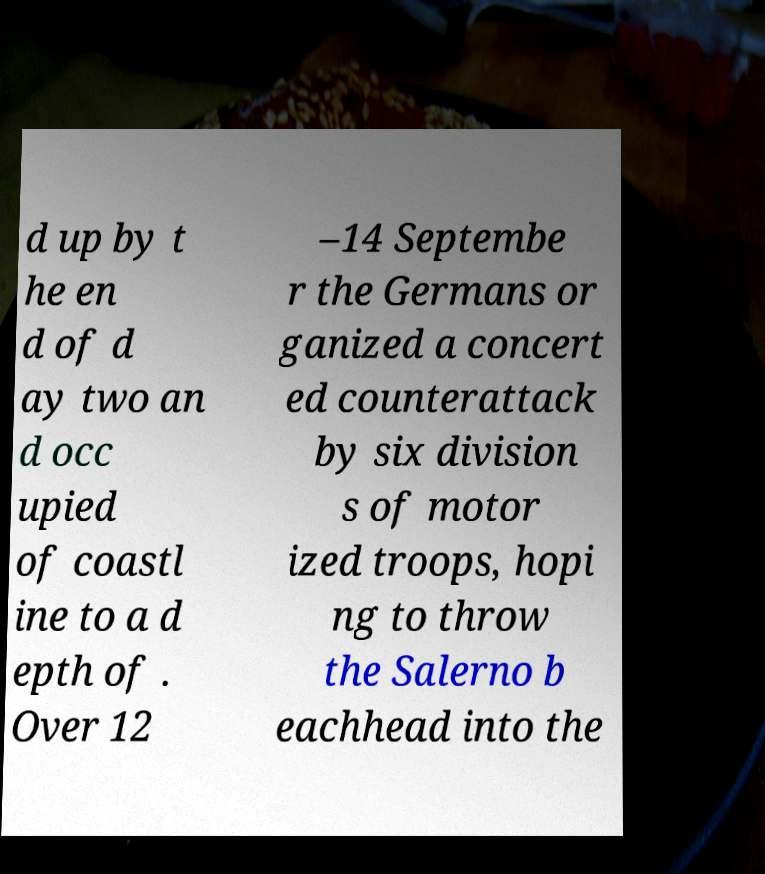Can you accurately transcribe the text from the provided image for me? d up by t he en d of d ay two an d occ upied of coastl ine to a d epth of . Over 12 –14 Septembe r the Germans or ganized a concert ed counterattack by six division s of motor ized troops, hopi ng to throw the Salerno b eachhead into the 